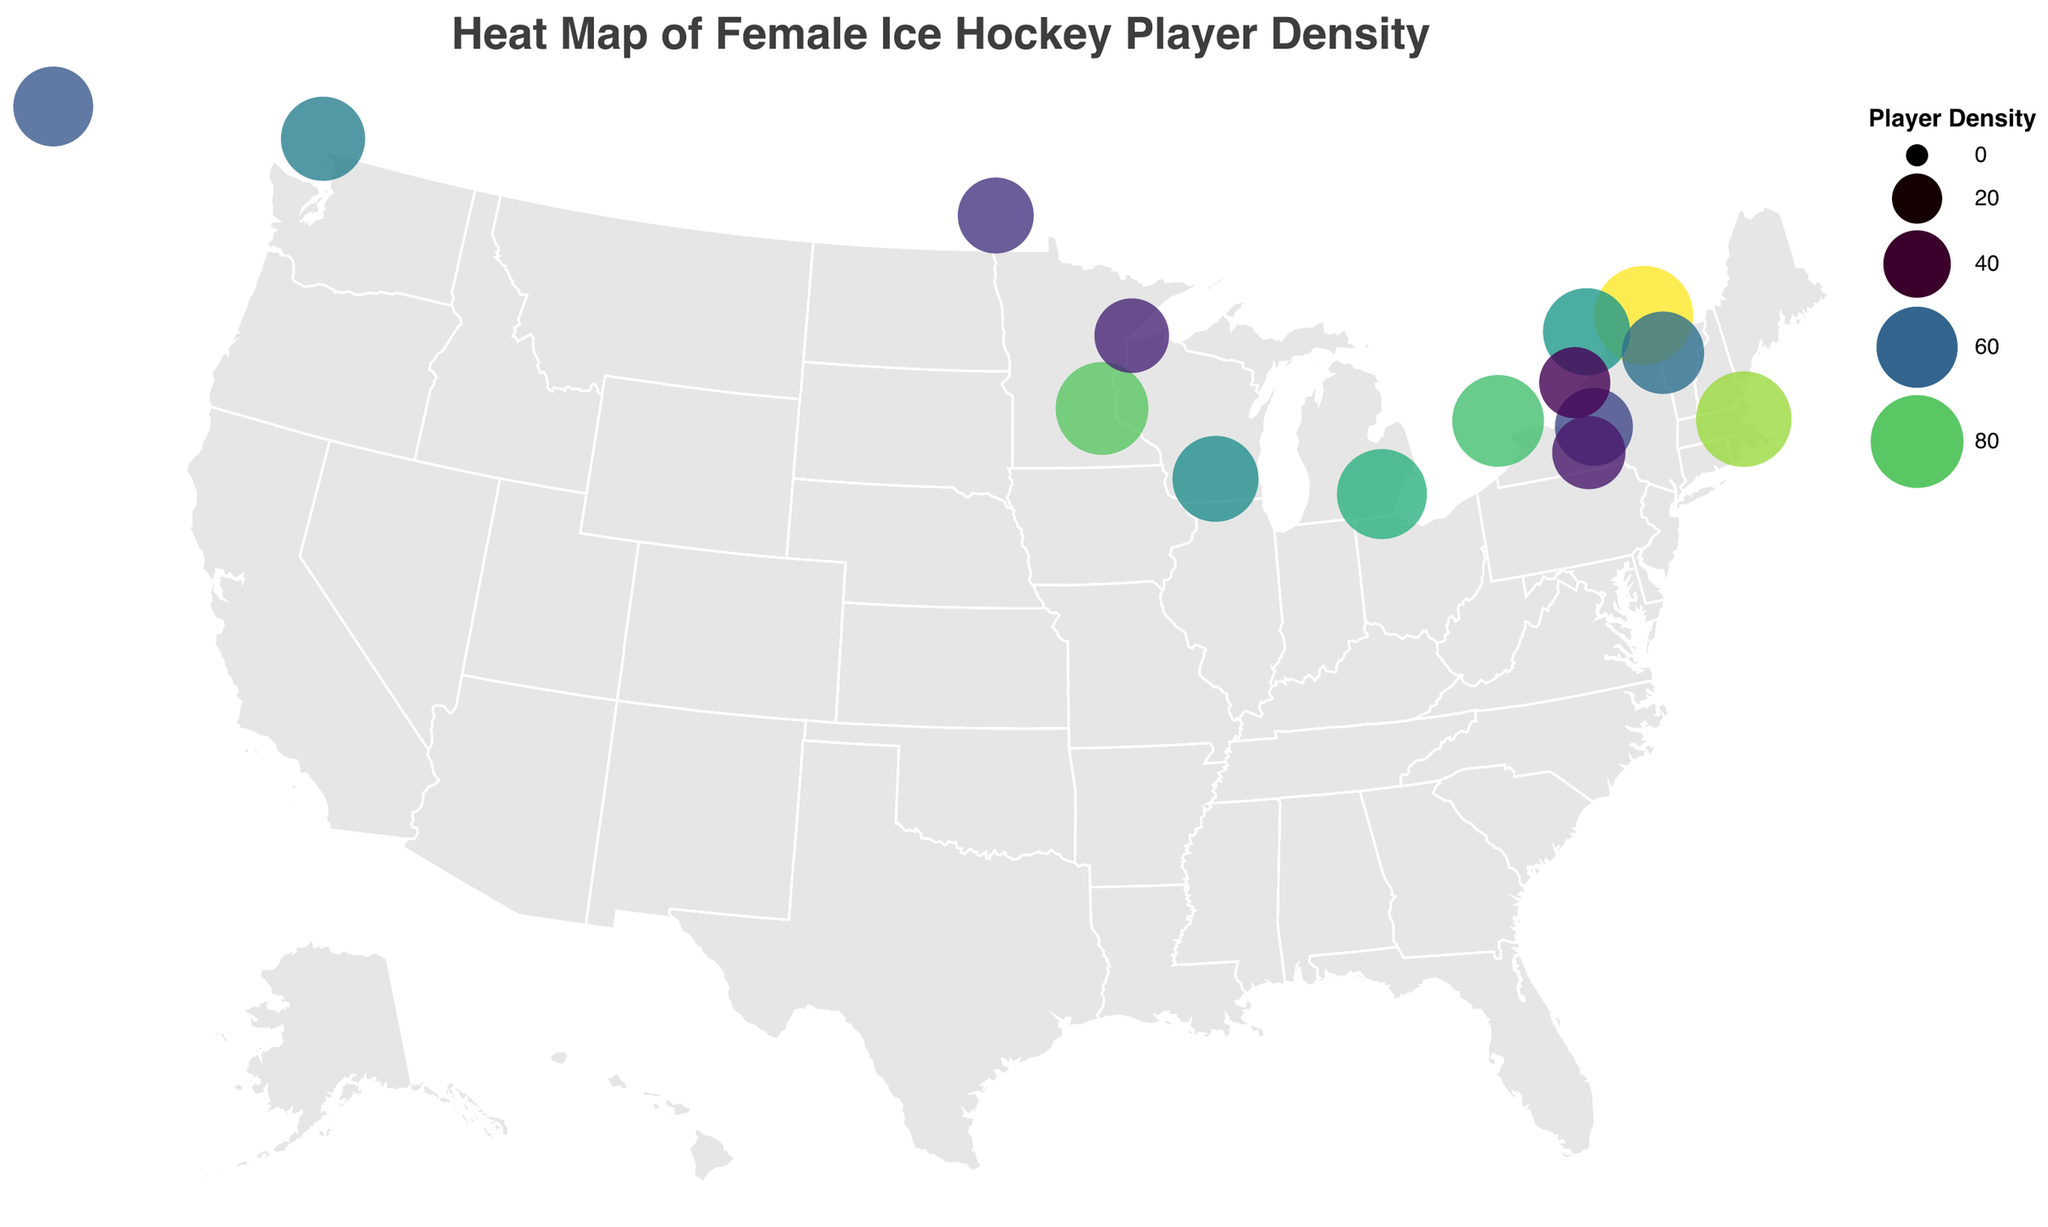What is the title of the heat map? The title is displayed at the top of the plot, written in large, bold text.
Answer: Heat Map of Female Ice Hockey Player Density Which city has the highest female ice hockey player density? Montreal has the largest circle and the deepest color, indicating the highest player density.
Answer: Montreal Which city has a higher player density, Ottawa or Syracuse? By comparing the size and color of the circles representing Ottawa and Syracuse, Ottawa's circle is larger and darker, indicating a higher player density.
Answer: Ottawa What is the player density in Ithaca? Hovering over or identifying the circle for Ithaca, the tooltip indicates the player density.
Answer: 48 Calculate the average player density of Canadian cities. Calculate the mean of the player densities for Montreal, Toronto, Vancouver, Ottawa, Edmonton, Winnipeg, and Kingston: (92 + 78 + 65 + 70 + 58 + 52 + 45) / 7.
Answer: 65.71 Which city in the USA has the closest player density to that of Kingston? Compare the player density value of Kingston (45) with each US city and identify the closest match, which is Ithaca at 48.
Answer: Ithaca How many cities have a player density greater than 60? Count the circles with a player density above 60.
Answer: 10 Which US state has the most cities listed with female ice hockey player density data? Identify the state with the most number of circles within its borders. Minnesota has two cities: Minneapolis and Duluth.
Answer: Minnesota Describe the general trend of player density between the northern US and Canada. Compare the overall sizes and colors of circles in Canadian cities versus northern US cities. Canadian cities generally have a higher player density indicated by larger and darker circles.
Answer: Higher in Canada 